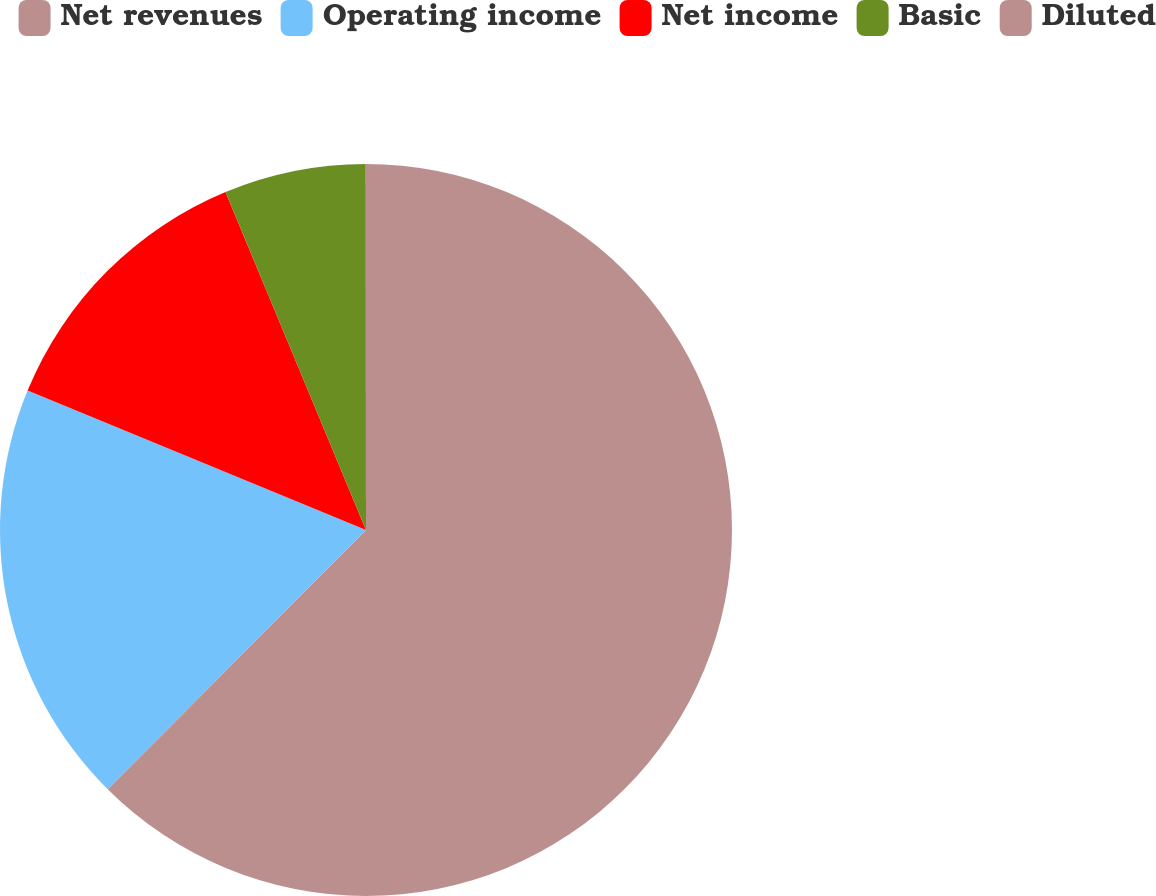Convert chart to OTSL. <chart><loc_0><loc_0><loc_500><loc_500><pie_chart><fcel>Net revenues<fcel>Operating income<fcel>Net income<fcel>Basic<fcel>Diluted<nl><fcel>62.47%<fcel>18.75%<fcel>12.51%<fcel>6.26%<fcel>0.01%<nl></chart> 